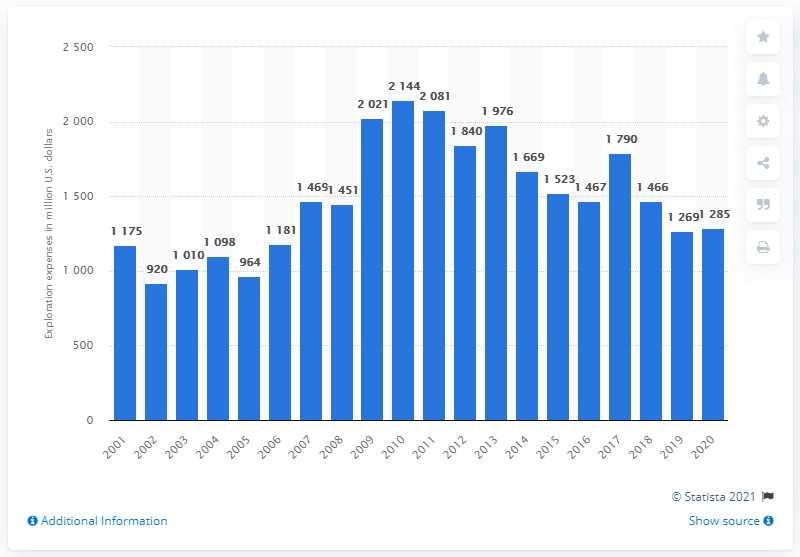Draw attention to some important aspects in this diagram. In 2020, ExxonMobil invested a significant amount in exploration activities, with a total expenditure of $1,285 million. 